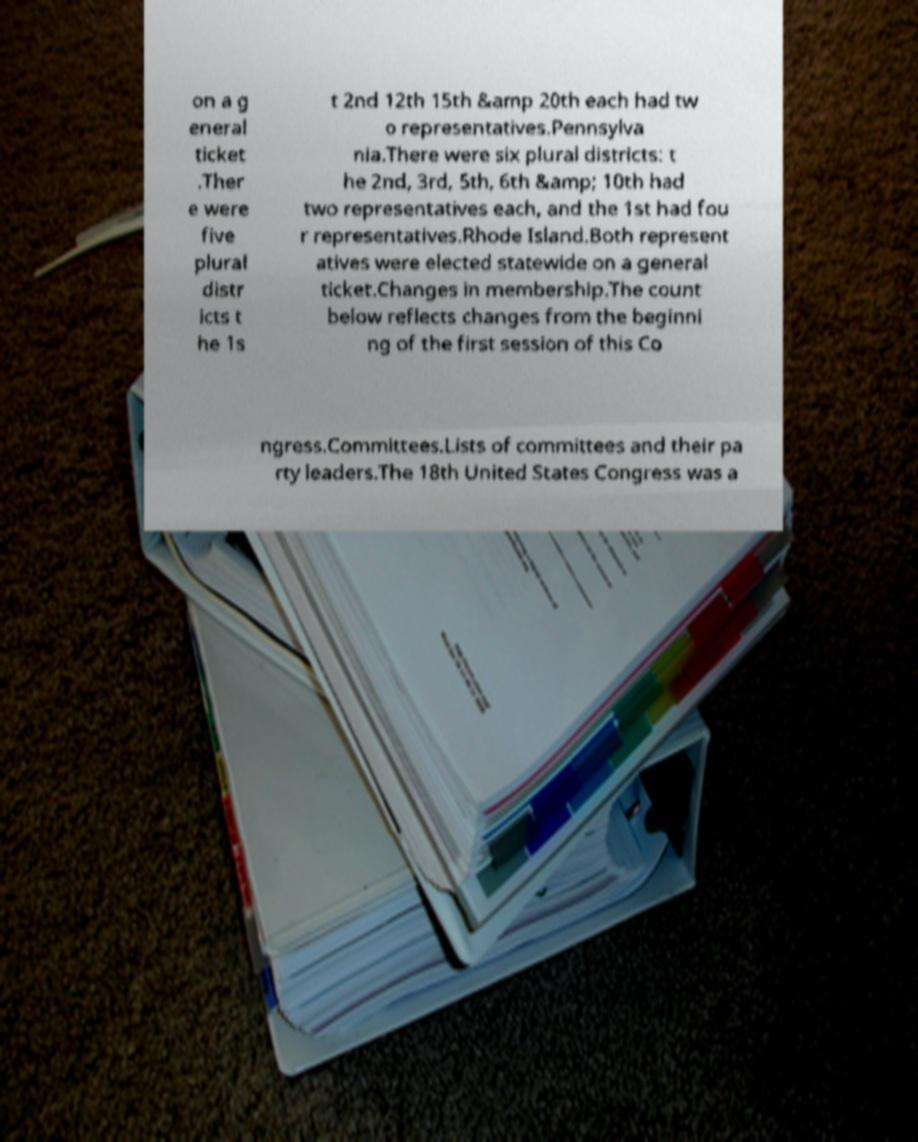Please read and relay the text visible in this image. What does it say? on a g eneral ticket .Ther e were five plural distr icts t he 1s t 2nd 12th 15th &amp 20th each had tw o representatives.Pennsylva nia.There were six plural districts: t he 2nd, 3rd, 5th, 6th &amp; 10th had two representatives each, and the 1st had fou r representatives.Rhode Island.Both represent atives were elected statewide on a general ticket.Changes in membership.The count below reflects changes from the beginni ng of the first session of this Co ngress.Committees.Lists of committees and their pa rty leaders.The 18th United States Congress was a 